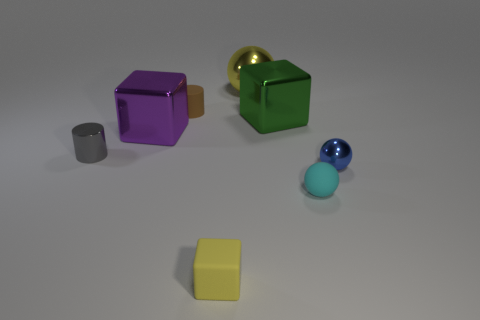How many other objects are there of the same color as the matte cube?
Give a very brief answer. 1. There is a metal cube that is to the right of the yellow shiny thing; what color is it?
Your response must be concise. Green. Are there any blue metallic spheres of the same size as the cyan rubber sphere?
Give a very brief answer. Yes. What material is the yellow cube that is the same size as the cyan rubber sphere?
Provide a short and direct response. Rubber. How many objects are small cylinders that are behind the gray cylinder or large objects in front of the tiny matte cylinder?
Provide a short and direct response. 3. Are there any tiny yellow rubber objects of the same shape as the small gray object?
Give a very brief answer. No. There is a tiny block that is the same color as the large shiny ball; what material is it?
Give a very brief answer. Rubber. How many rubber things are either tiny balls or tiny red balls?
Keep it short and to the point. 1. What shape is the large yellow shiny thing?
Make the answer very short. Sphere. What number of yellow cubes have the same material as the tiny cyan sphere?
Provide a succinct answer. 1. 